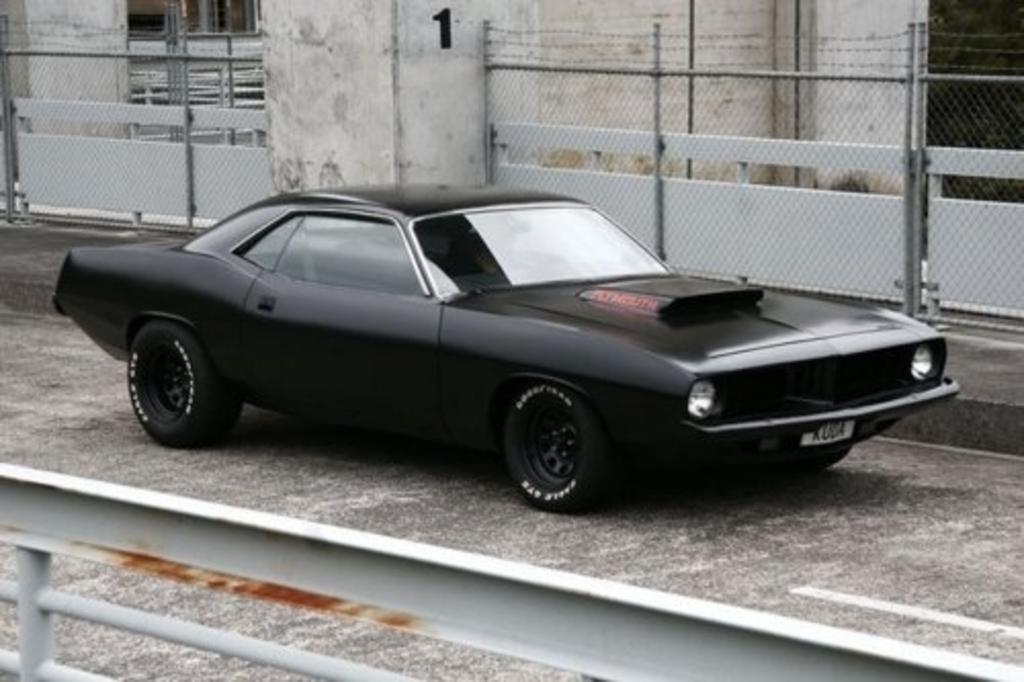In one or two sentences, can you explain what this image depicts? In the center of the image we can see a car. In the background of the image we can see the mesh, pillars, rods, wall, text on the wall. At the bottom of the image we can see the road and railing. 